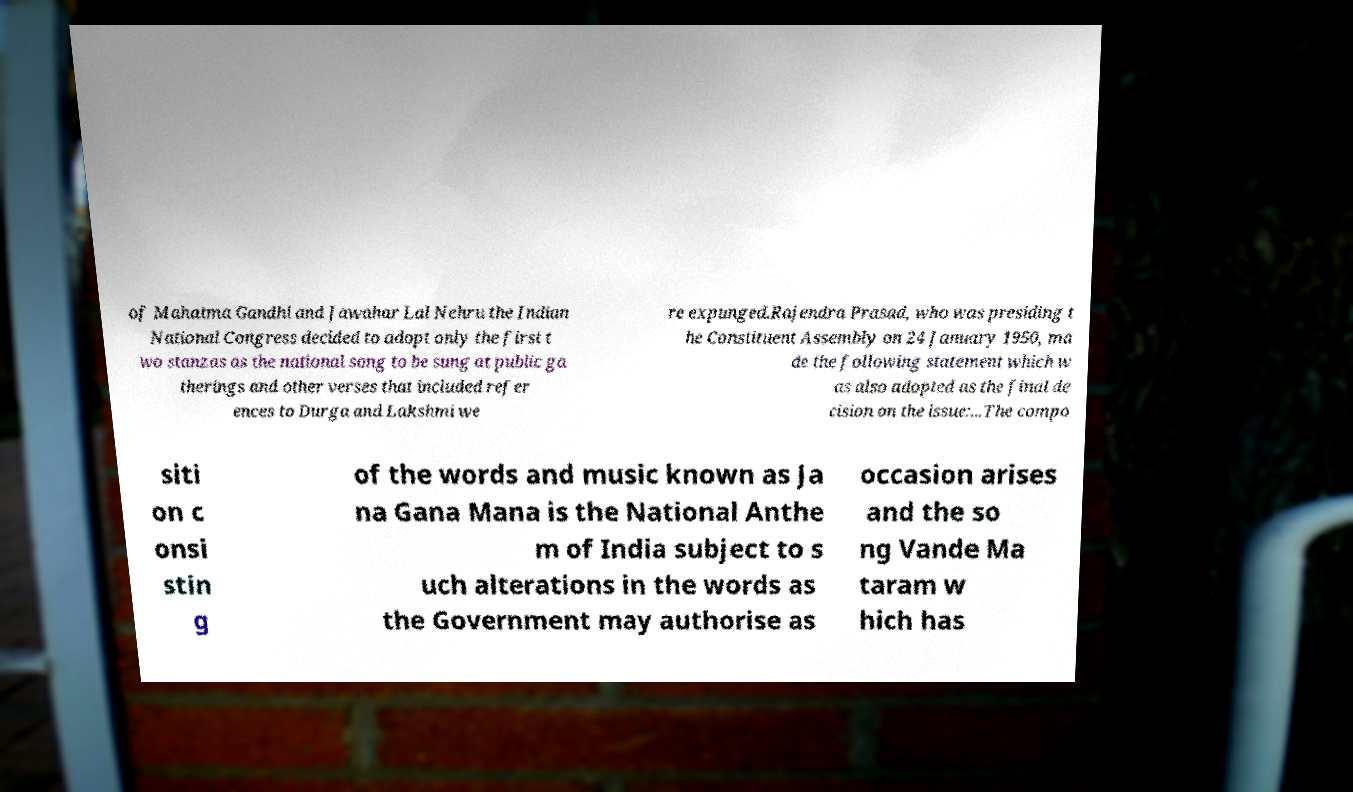Could you assist in decoding the text presented in this image and type it out clearly? of Mahatma Gandhi and Jawahar Lal Nehru the Indian National Congress decided to adopt only the first t wo stanzas as the national song to be sung at public ga therings and other verses that included refer ences to Durga and Lakshmi we re expunged.Rajendra Prasad, who was presiding t he Constituent Assembly on 24 January 1950, ma de the following statement which w as also adopted as the final de cision on the issue:...The compo siti on c onsi stin g of the words and music known as Ja na Gana Mana is the National Anthe m of India subject to s uch alterations in the words as the Government may authorise as occasion arises and the so ng Vande Ma taram w hich has 